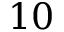<formula> <loc_0><loc_0><loc_500><loc_500>1 0</formula> 